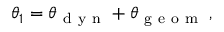<formula> <loc_0><loc_0><loc_500><loc_500>\theta _ { 1 } = \theta _ { d y n } + \theta _ { g e o m } \, ,</formula> 